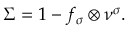Convert formula to latex. <formula><loc_0><loc_0><loc_500><loc_500>\Sigma = 1 - f _ { \sigma } \otimes \nu ^ { \sigma } .</formula> 